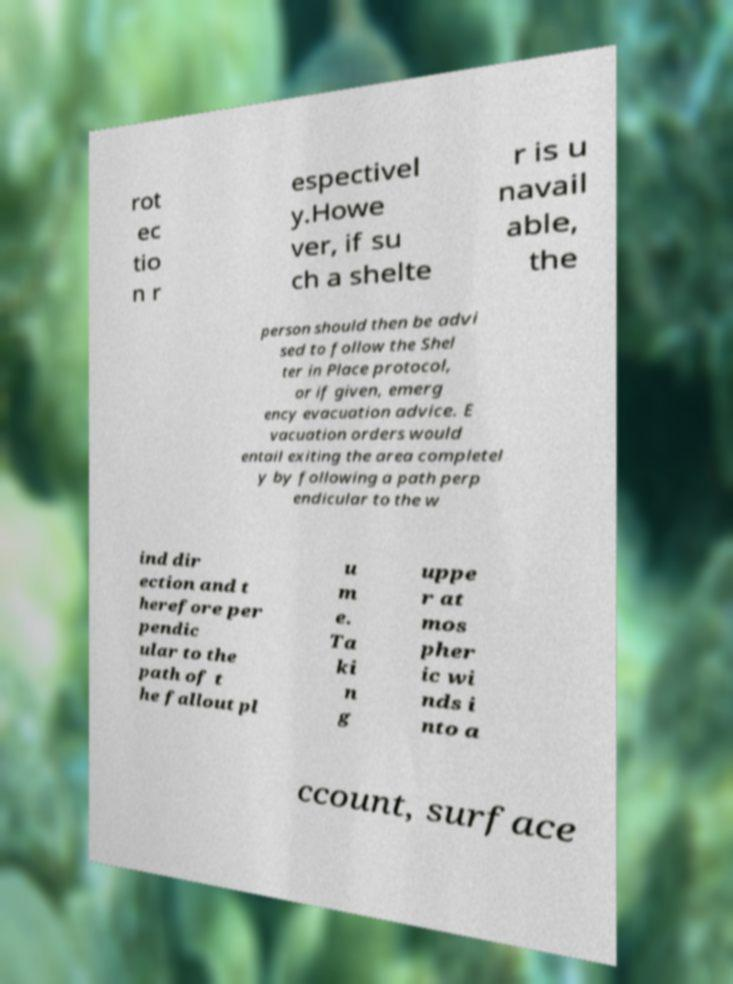I need the written content from this picture converted into text. Can you do that? rot ec tio n r espectivel y.Howe ver, if su ch a shelte r is u navail able, the person should then be advi sed to follow the Shel ter in Place protocol, or if given, emerg ency evacuation advice. E vacuation orders would entail exiting the area completel y by following a path perp endicular to the w ind dir ection and t herefore per pendic ular to the path of t he fallout pl u m e. Ta ki n g uppe r at mos pher ic wi nds i nto a ccount, surface 